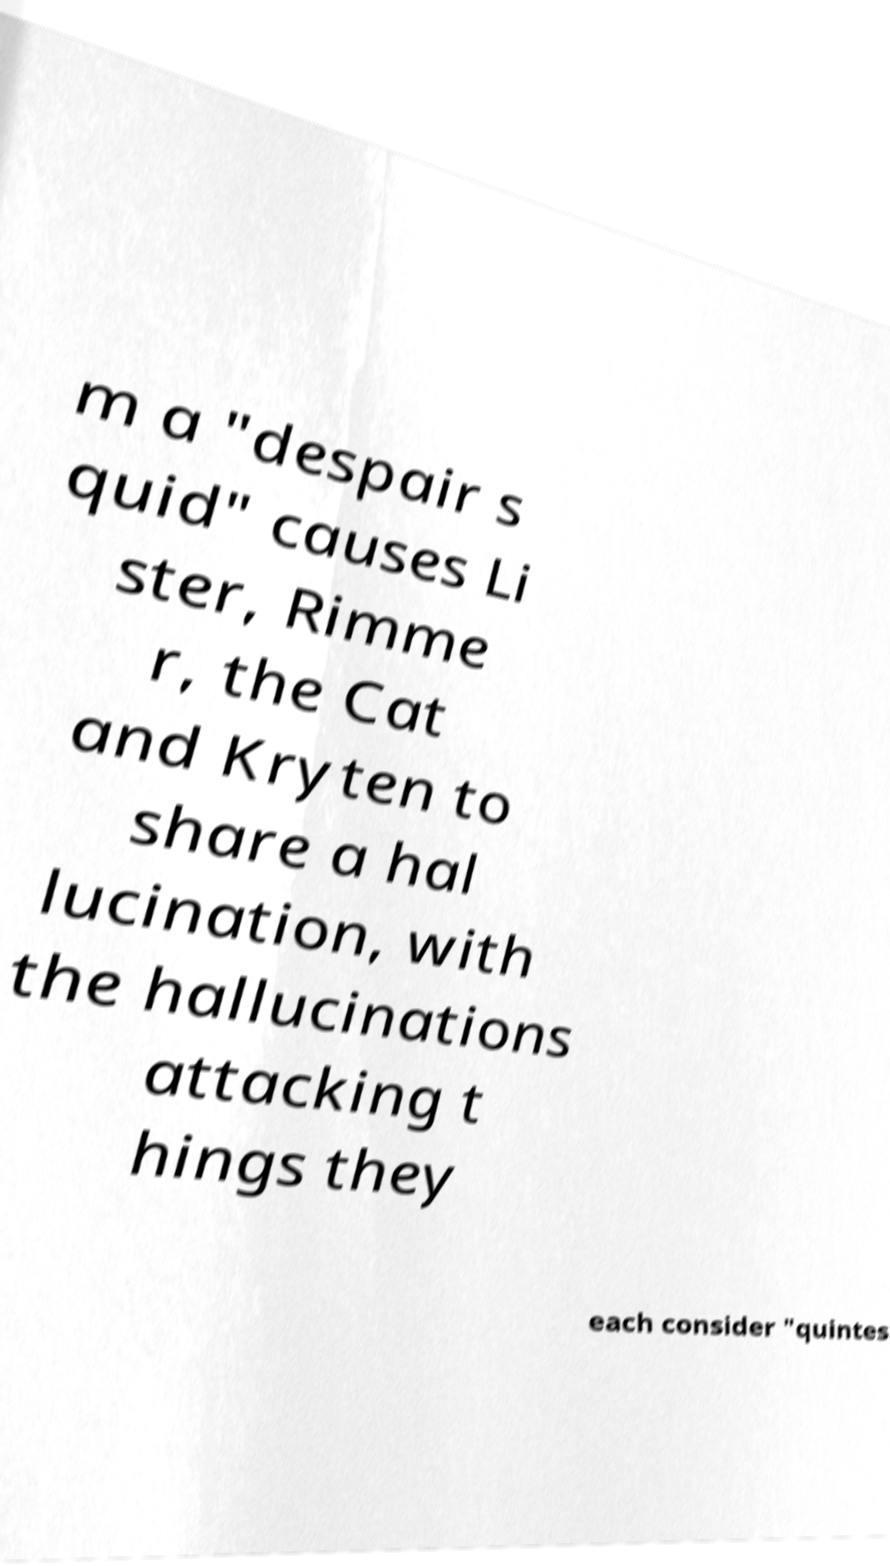I need the written content from this picture converted into text. Can you do that? m a "despair s quid" causes Li ster, Rimme r, the Cat and Kryten to share a hal lucination, with the hallucinations attacking t hings they each consider "quintes 